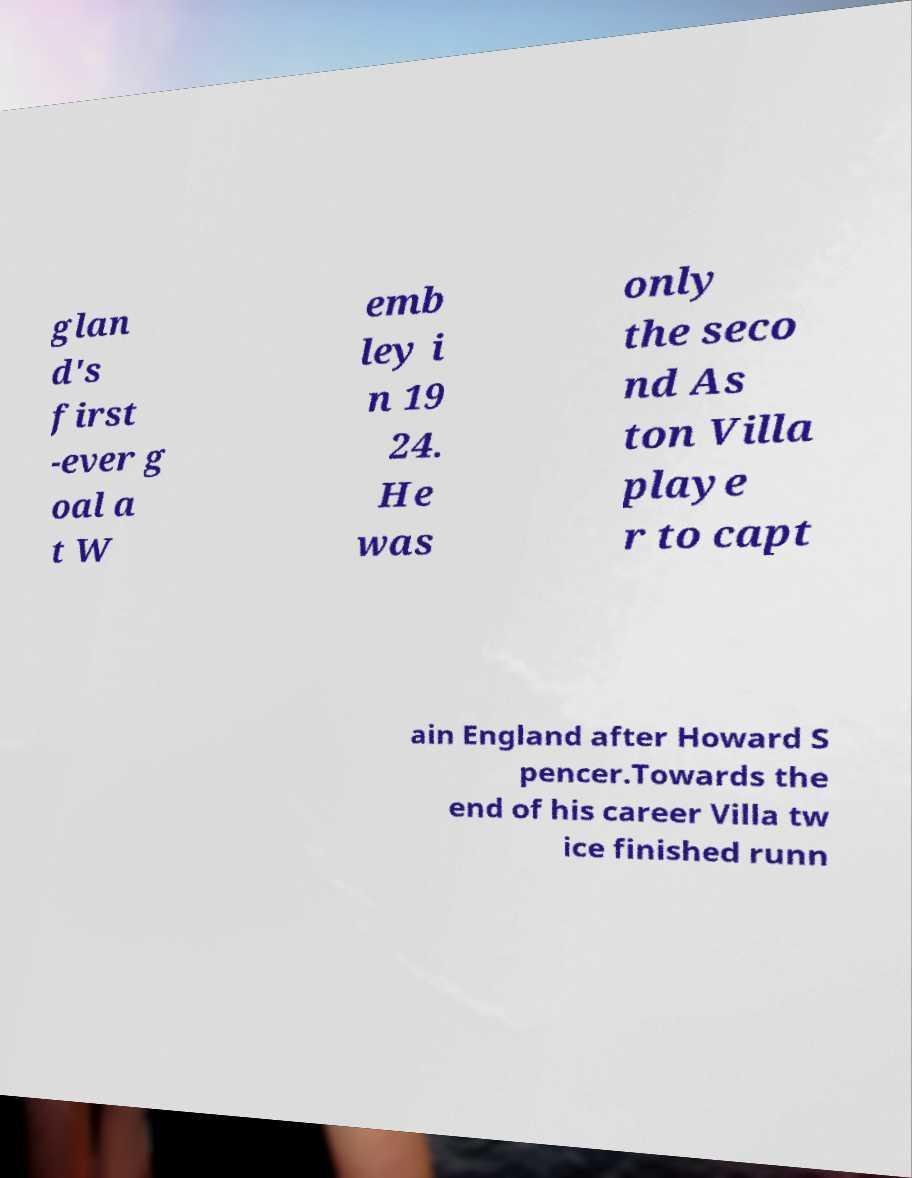Please identify and transcribe the text found in this image. glan d's first -ever g oal a t W emb ley i n 19 24. He was only the seco nd As ton Villa playe r to capt ain England after Howard S pencer.Towards the end of his career Villa tw ice finished runn 